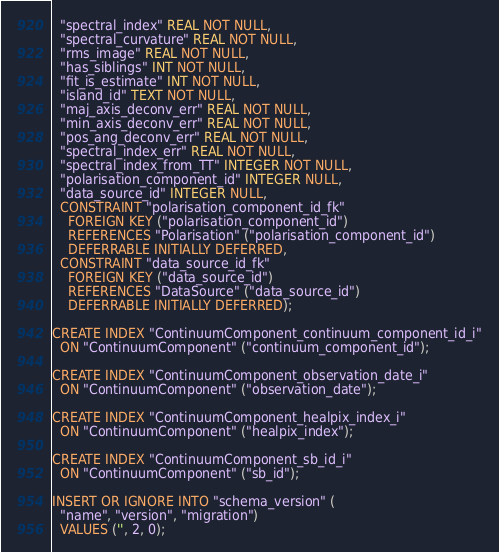<code> <loc_0><loc_0><loc_500><loc_500><_SQL_>  "spectral_index" REAL NOT NULL,
  "spectral_curvature" REAL NOT NULL,
  "rms_image" REAL NOT NULL,
  "has_siblings" INT NOT NULL,
  "fit_is_estimate" INT NOT NULL,
  "island_id" TEXT NOT NULL,
  "maj_axis_deconv_err" REAL NOT NULL,
  "min_axis_deconv_err" REAL NOT NULL,
  "pos_ang_deconv_err" REAL NOT NULL,
  "spectral_index_err" REAL NOT NULL,
  "spectral_index_from_TT" INTEGER NOT NULL,
  "polarisation_component_id" INTEGER NULL,
  "data_source_id" INTEGER NULL,
  CONSTRAINT "polarisation_component_id_fk"
    FOREIGN KEY ("polarisation_component_id")
    REFERENCES "Polarisation" ("polarisation_component_id")
    DEFERRABLE INITIALLY DEFERRED,
  CONSTRAINT "data_source_id_fk"
    FOREIGN KEY ("data_source_id")
    REFERENCES "DataSource" ("data_source_id")
    DEFERRABLE INITIALLY DEFERRED);

CREATE INDEX "ContinuumComponent_continuum_component_id_i"
  ON "ContinuumComponent" ("continuum_component_id");

CREATE INDEX "ContinuumComponent_observation_date_i"
  ON "ContinuumComponent" ("observation_date");

CREATE INDEX "ContinuumComponent_healpix_index_i"
  ON "ContinuumComponent" ("healpix_index");

CREATE INDEX "ContinuumComponent_sb_id_i"
  ON "ContinuumComponent" ("sb_id");

INSERT OR IGNORE INTO "schema_version" (
  "name", "version", "migration")
  VALUES ('', 2, 0);

</code> 